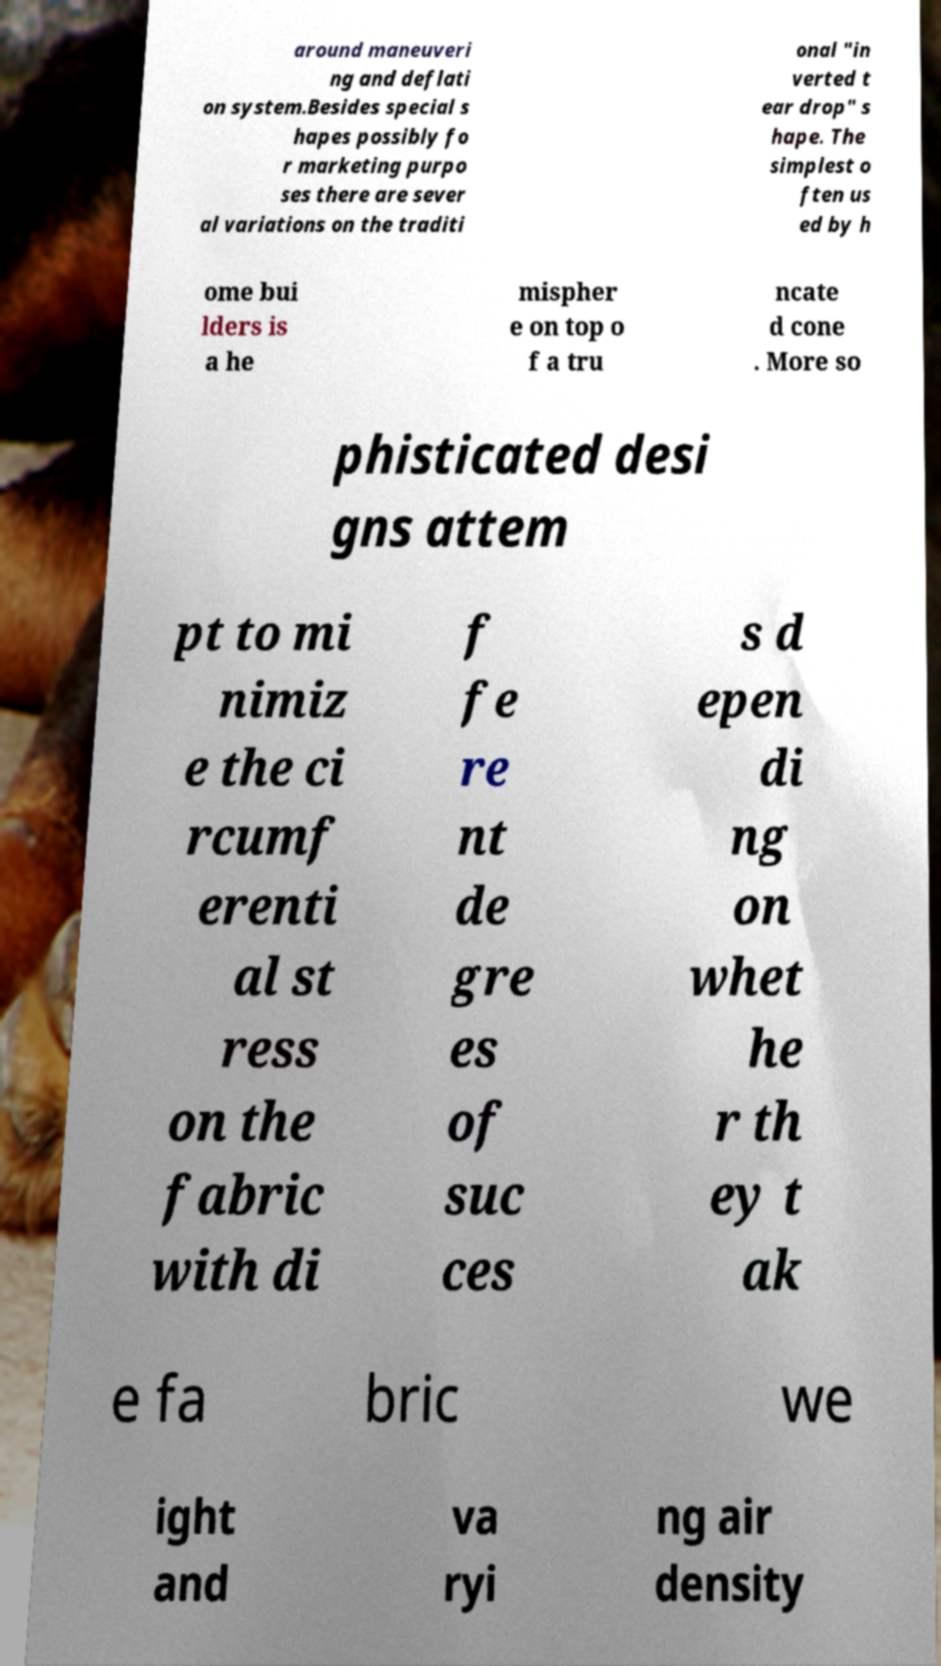Please read and relay the text visible in this image. What does it say? around maneuveri ng and deflati on system.Besides special s hapes possibly fo r marketing purpo ses there are sever al variations on the traditi onal "in verted t ear drop" s hape. The simplest o ften us ed by h ome bui lders is a he mispher e on top o f a tru ncate d cone . More so phisticated desi gns attem pt to mi nimiz e the ci rcumf erenti al st ress on the fabric with di f fe re nt de gre es of suc ces s d epen di ng on whet he r th ey t ak e fa bric we ight and va ryi ng air density 